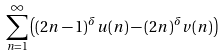<formula> <loc_0><loc_0><loc_500><loc_500>\sum _ { n = 1 } ^ { \infty } \left ( ( 2 n - 1 ) ^ { \delta } u ( n ) - ( 2 n ) ^ { \delta } v ( n ) \right )</formula> 